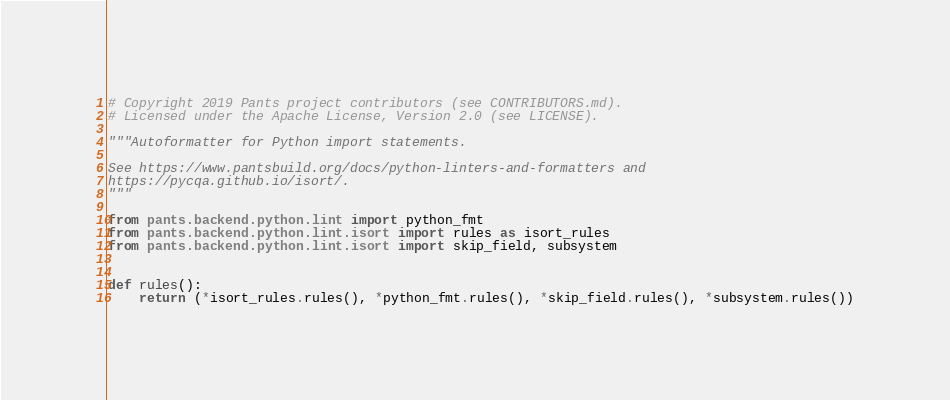<code> <loc_0><loc_0><loc_500><loc_500><_Python_># Copyright 2019 Pants project contributors (see CONTRIBUTORS.md).
# Licensed under the Apache License, Version 2.0 (see LICENSE).

"""Autoformatter for Python import statements.

See https://www.pantsbuild.org/docs/python-linters-and-formatters and
https://pycqa.github.io/isort/.
"""

from pants.backend.python.lint import python_fmt
from pants.backend.python.lint.isort import rules as isort_rules
from pants.backend.python.lint.isort import skip_field, subsystem


def rules():
    return (*isort_rules.rules(), *python_fmt.rules(), *skip_field.rules(), *subsystem.rules())
</code> 